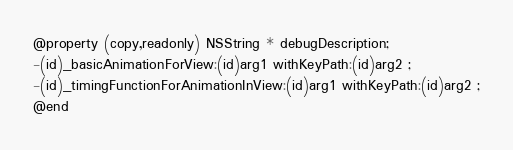<code> <loc_0><loc_0><loc_500><loc_500><_C_>@property (copy,readonly) NSString * debugDescription; 
-(id)_basicAnimationForView:(id)arg1 withKeyPath:(id)arg2 ;
-(id)_timingFunctionForAnimationInView:(id)arg1 withKeyPath:(id)arg2 ;
@end

</code> 